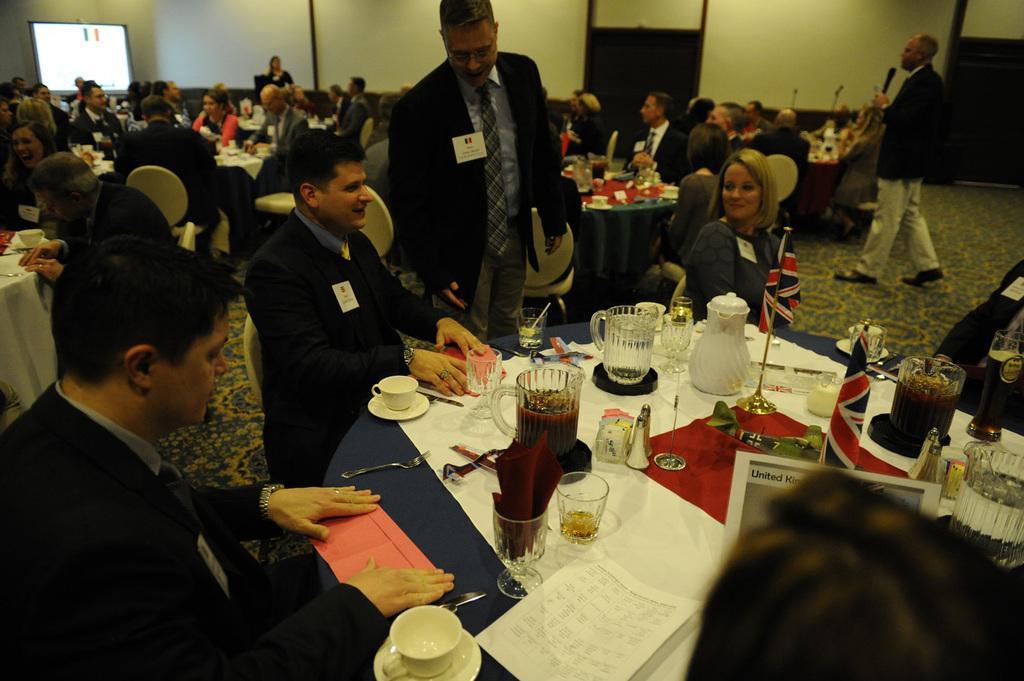In one or two sentences, can you explain what this image depicts? In this picture we can see some persons sitting on the chairs. This is the table. On the table there is a cup, paper, glasses, jar, and a flag. Even we can see two persons are standing on the floor. This is the wall and there is a screen. 